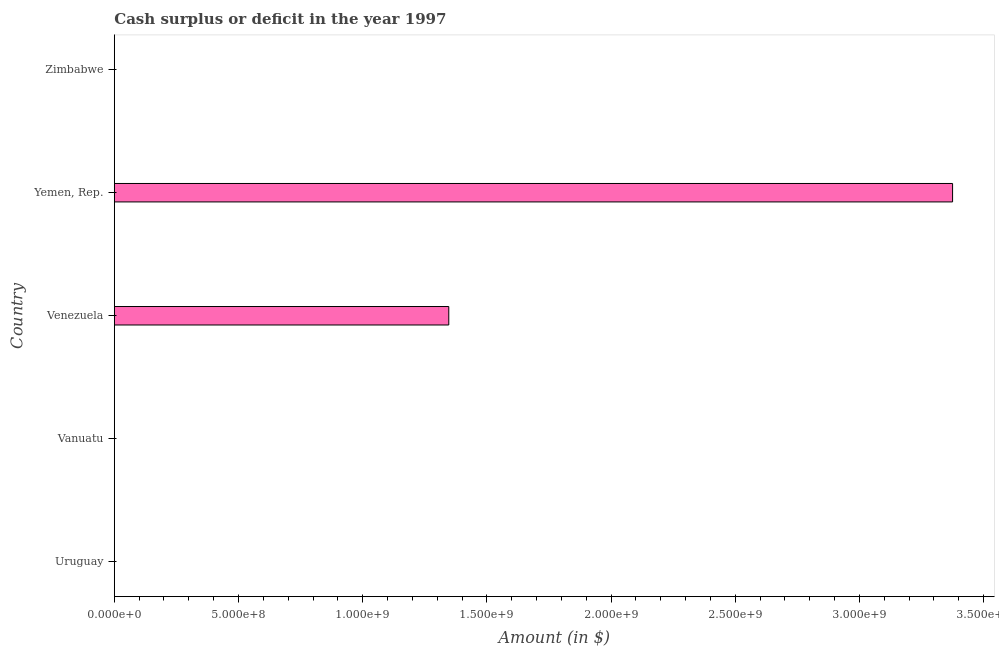Does the graph contain any zero values?
Provide a succinct answer. Yes. What is the title of the graph?
Make the answer very short. Cash surplus or deficit in the year 1997. What is the label or title of the X-axis?
Your answer should be compact. Amount (in $). What is the cash surplus or deficit in Yemen, Rep.?
Provide a succinct answer. 3.38e+09. Across all countries, what is the maximum cash surplus or deficit?
Offer a terse response. 3.38e+09. In which country was the cash surplus or deficit maximum?
Your answer should be very brief. Yemen, Rep. What is the sum of the cash surplus or deficit?
Provide a short and direct response. 4.72e+09. What is the difference between the cash surplus or deficit in Venezuela and Yemen, Rep.?
Ensure brevity in your answer.  -2.03e+09. What is the average cash surplus or deficit per country?
Offer a terse response. 9.44e+08. What is the ratio of the cash surplus or deficit in Venezuela to that in Yemen, Rep.?
Make the answer very short. 0.4. Is the difference between the cash surplus or deficit in Venezuela and Yemen, Rep. greater than the difference between any two countries?
Offer a very short reply. No. What is the difference between the highest and the lowest cash surplus or deficit?
Offer a very short reply. 3.38e+09. Are all the bars in the graph horizontal?
Offer a terse response. Yes. How many countries are there in the graph?
Your response must be concise. 5. What is the difference between two consecutive major ticks on the X-axis?
Keep it short and to the point. 5.00e+08. What is the Amount (in $) in Uruguay?
Your response must be concise. 0. What is the Amount (in $) in Venezuela?
Provide a succinct answer. 1.35e+09. What is the Amount (in $) of Yemen, Rep.?
Ensure brevity in your answer.  3.38e+09. What is the Amount (in $) in Zimbabwe?
Offer a terse response. 0. What is the difference between the Amount (in $) in Venezuela and Yemen, Rep.?
Keep it short and to the point. -2.03e+09. What is the ratio of the Amount (in $) in Venezuela to that in Yemen, Rep.?
Provide a short and direct response. 0.4. 